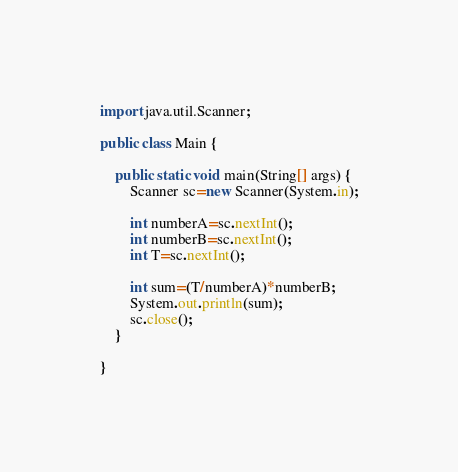Convert code to text. <code><loc_0><loc_0><loc_500><loc_500><_Java_>import java.util.Scanner;

public class Main {

	public static void main(String[] args) {
		Scanner sc=new Scanner(System.in);

		int numberA=sc.nextInt();
		int numberB=sc.nextInt();
		int T=sc.nextInt();

		int sum=(T/numberA)*numberB;
		System.out.println(sum);
		sc.close();
	}

}
</code> 